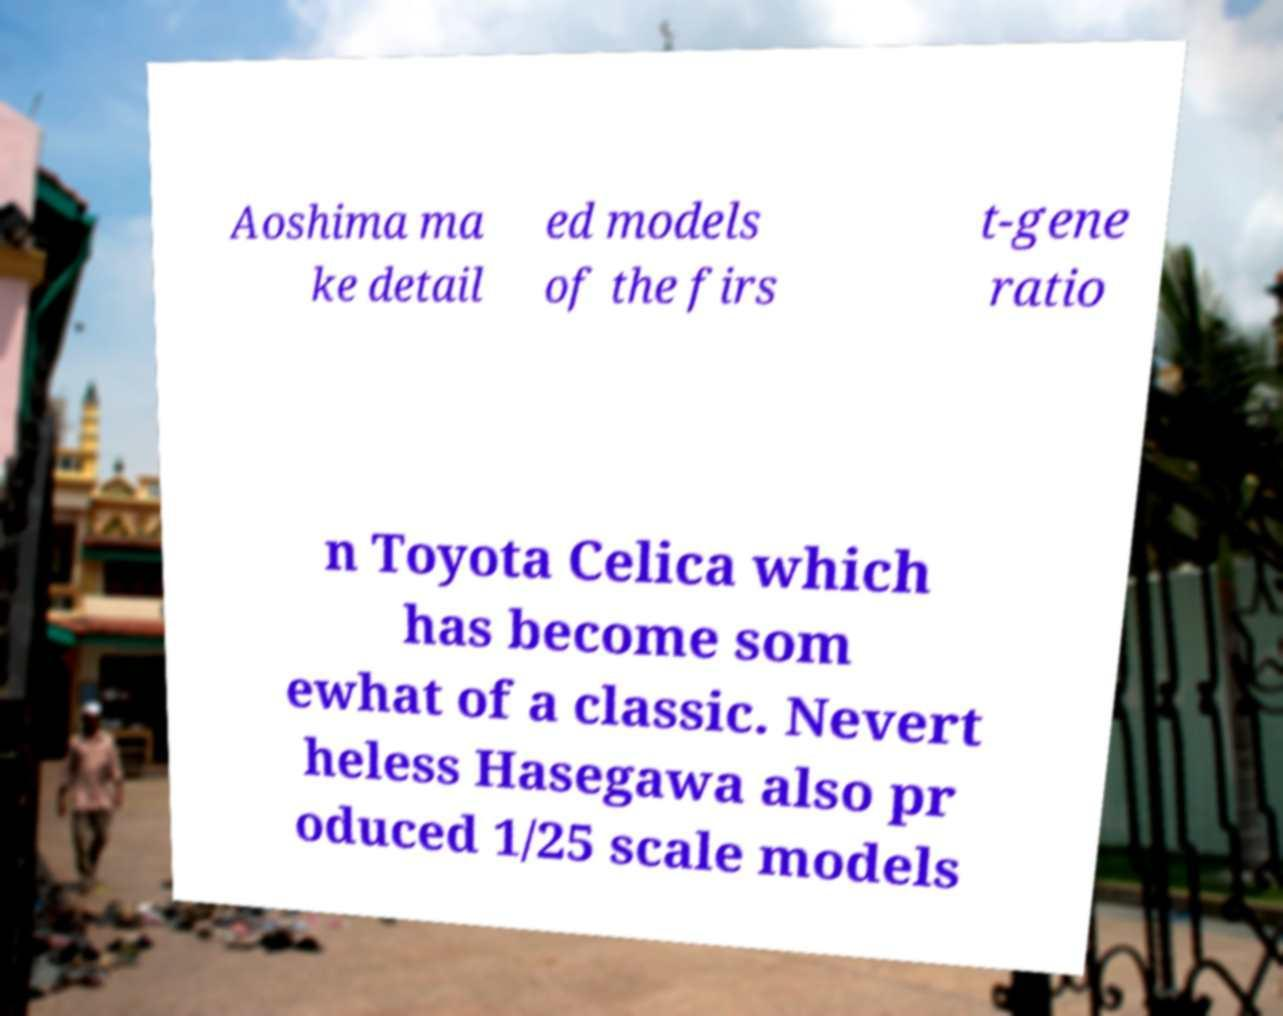I need the written content from this picture converted into text. Can you do that? Aoshima ma ke detail ed models of the firs t-gene ratio n Toyota Celica which has become som ewhat of a classic. Nevert heless Hasegawa also pr oduced 1/25 scale models 